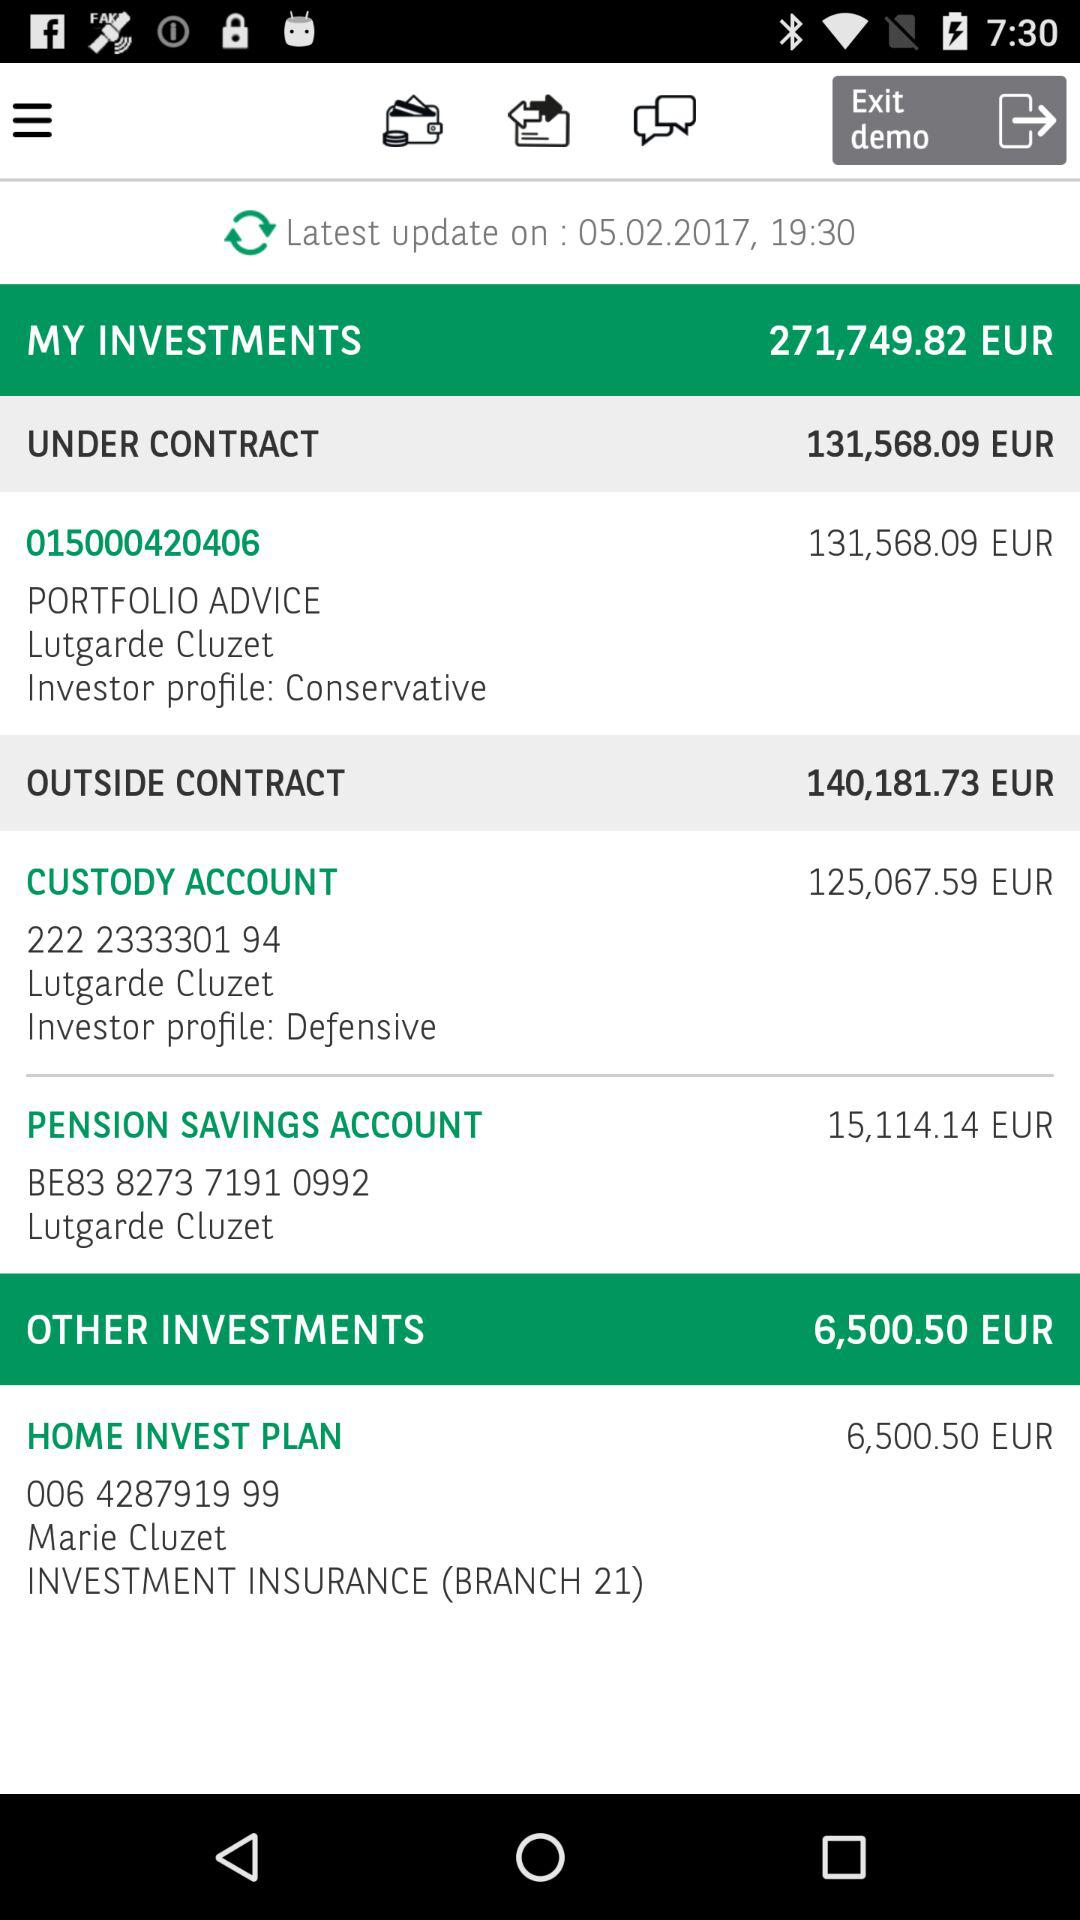How much is the other investment? The other investment is 6,500.50 EUR. 